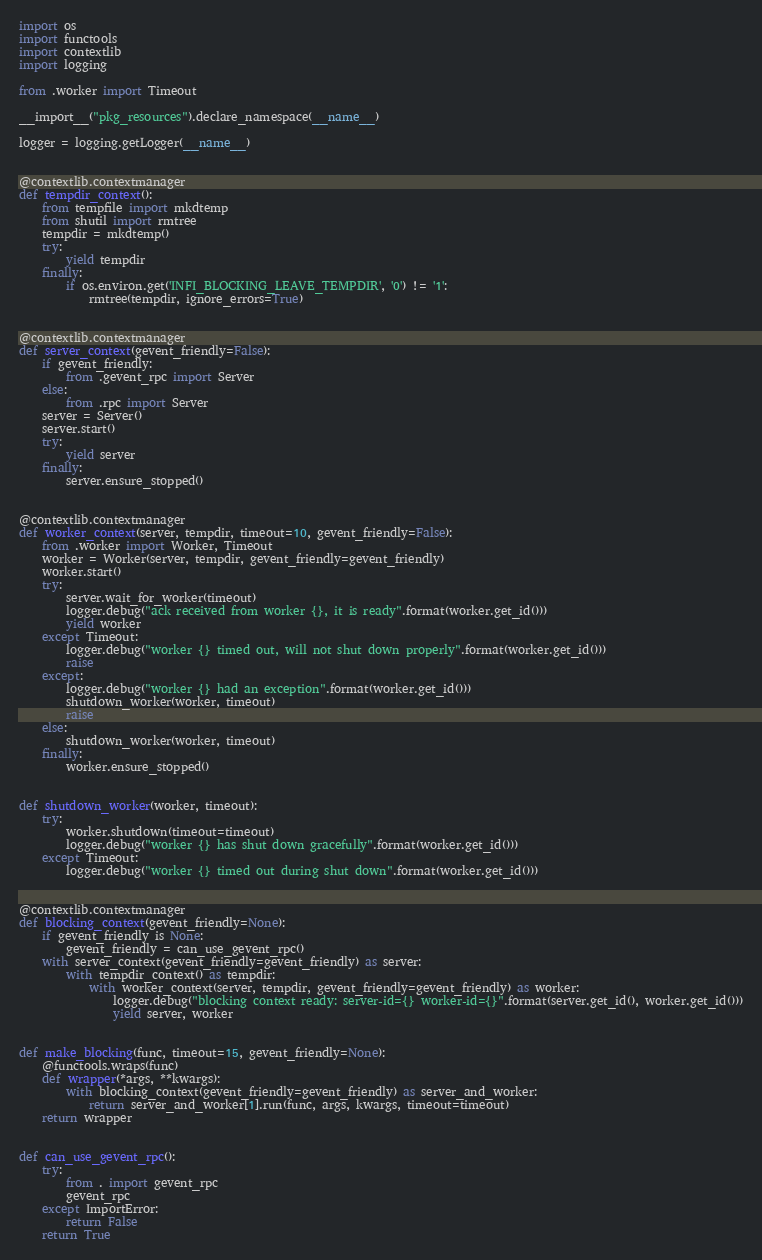<code> <loc_0><loc_0><loc_500><loc_500><_Python_>import os
import functools
import contextlib
import logging

from .worker import Timeout

__import__("pkg_resources").declare_namespace(__name__)

logger = logging.getLogger(__name__)


@contextlib.contextmanager
def tempdir_context():
    from tempfile import mkdtemp
    from shutil import rmtree
    tempdir = mkdtemp()
    try:
        yield tempdir
    finally:
        if os.environ.get('INFI_BLOCKING_LEAVE_TEMPDIR', '0') != '1':
            rmtree(tempdir, ignore_errors=True)


@contextlib.contextmanager
def server_context(gevent_friendly=False):
    if gevent_friendly:
        from .gevent_rpc import Server
    else:
        from .rpc import Server
    server = Server()
    server.start()
    try:
        yield server
    finally:
        server.ensure_stopped()


@contextlib.contextmanager
def worker_context(server, tempdir, timeout=10, gevent_friendly=False):
    from .worker import Worker, Timeout
    worker = Worker(server, tempdir, gevent_friendly=gevent_friendly)
    worker.start()
    try:
        server.wait_for_worker(timeout)
        logger.debug("ack received from worker {}, it is ready".format(worker.get_id()))
        yield worker
    except Timeout:
        logger.debug("worker {} timed out, will not shut down properly".format(worker.get_id()))
        raise
    except:
        logger.debug("worker {} had an exception".format(worker.get_id()))
        shutdown_worker(worker, timeout)
        raise
    else:
        shutdown_worker(worker, timeout)
    finally:
        worker.ensure_stopped()


def shutdown_worker(worker, timeout):
    try:
        worker.shutdown(timeout=timeout)
        logger.debug("worker {} has shut down gracefully".format(worker.get_id()))
    except Timeout:
        logger.debug("worker {} timed out during shut down".format(worker.get_id()))


@contextlib.contextmanager
def blocking_context(gevent_friendly=None):
    if gevent_friendly is None:
        gevent_friendly = can_use_gevent_rpc()
    with server_context(gevent_friendly=gevent_friendly) as server:
        with tempdir_context() as tempdir:
            with worker_context(server, tempdir, gevent_friendly=gevent_friendly) as worker:
                logger.debug("blocking context ready: server-id={} worker-id={}".format(server.get_id(), worker.get_id()))
                yield server, worker


def make_blocking(func, timeout=15, gevent_friendly=None):
    @functools.wraps(func)
    def wrapper(*args, **kwargs):
        with blocking_context(gevent_friendly=gevent_friendly) as server_and_worker:
            return server_and_worker[1].run(func, args, kwargs, timeout=timeout)
    return wrapper


def can_use_gevent_rpc():
    try:
        from . import gevent_rpc
        gevent_rpc
    except ImportError:
        return False
    return True
</code> 